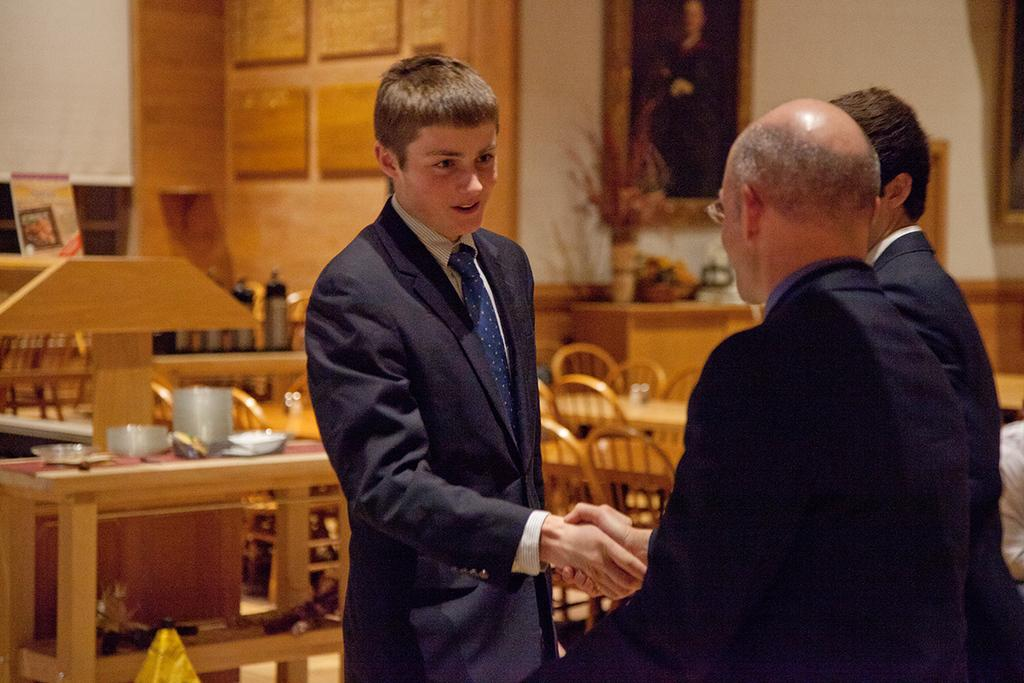How many people are present in the image? There are four people in the image. What are the positions of the people in the image? Three of the people are standing, and one person is seated on a chair. What can be seen in the background of the image? There is a table with objects on it and a wall painting in the background of the image. What type of bushes can be seen in the image? There are no bushes present in the image. What team are the people in the image supporting? There is no indication of a team or any sports-related activity in the image. 